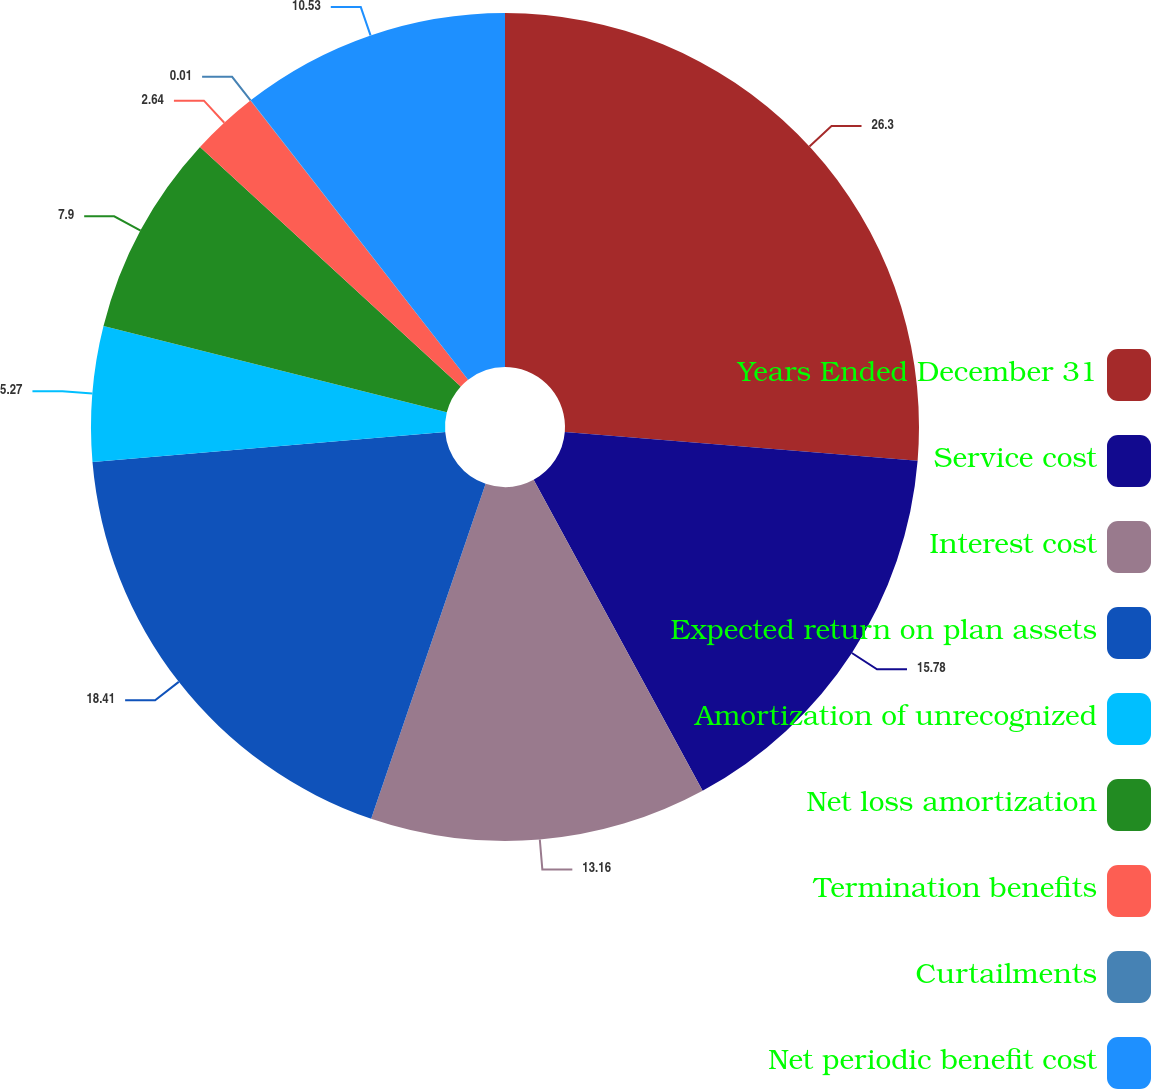<chart> <loc_0><loc_0><loc_500><loc_500><pie_chart><fcel>Years Ended December 31<fcel>Service cost<fcel>Interest cost<fcel>Expected return on plan assets<fcel>Amortization of unrecognized<fcel>Net loss amortization<fcel>Termination benefits<fcel>Curtailments<fcel>Net periodic benefit cost<nl><fcel>26.3%<fcel>15.78%<fcel>13.16%<fcel>18.41%<fcel>5.27%<fcel>7.9%<fcel>2.64%<fcel>0.01%<fcel>10.53%<nl></chart> 